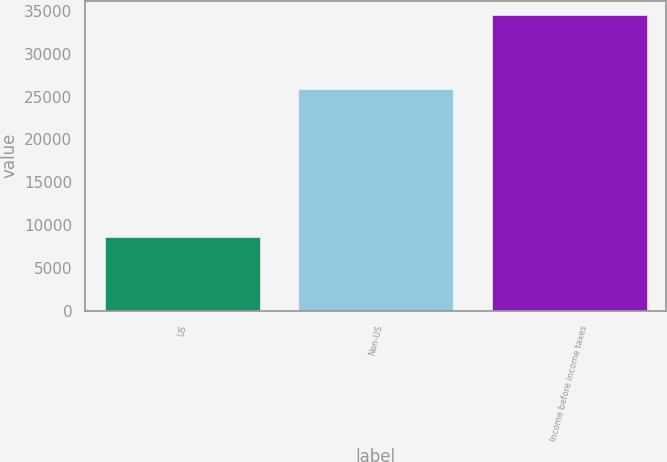Convert chart. <chart><loc_0><loc_0><loc_500><loc_500><bar_chart><fcel>US<fcel>Non-US<fcel>Income before income taxes<nl><fcel>8622<fcel>25840<fcel>34462<nl></chart> 